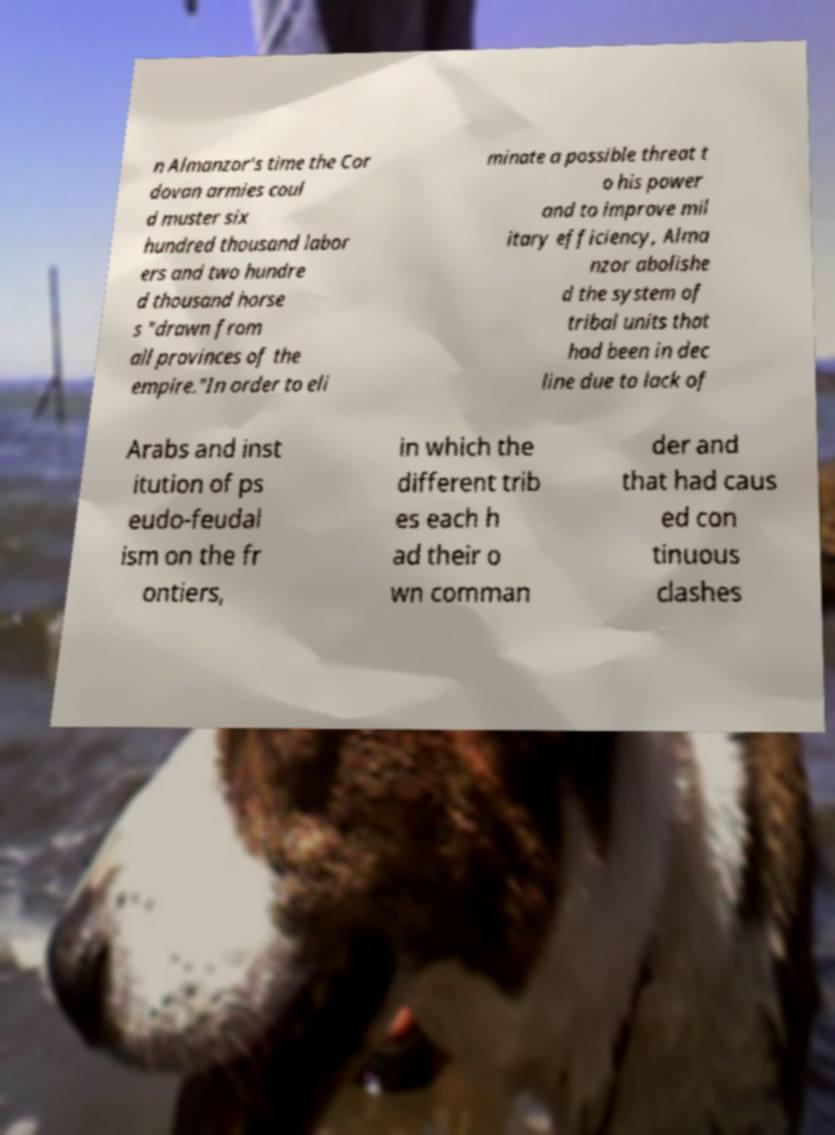Can you accurately transcribe the text from the provided image for me? n Almanzor's time the Cor dovan armies coul d muster six hundred thousand labor ers and two hundre d thousand horse s "drawn from all provinces of the empire."In order to eli minate a possible threat t o his power and to improve mil itary efficiency, Alma nzor abolishe d the system of tribal units that had been in dec line due to lack of Arabs and inst itution of ps eudo-feudal ism on the fr ontiers, in which the different trib es each h ad their o wn comman der and that had caus ed con tinuous clashes 